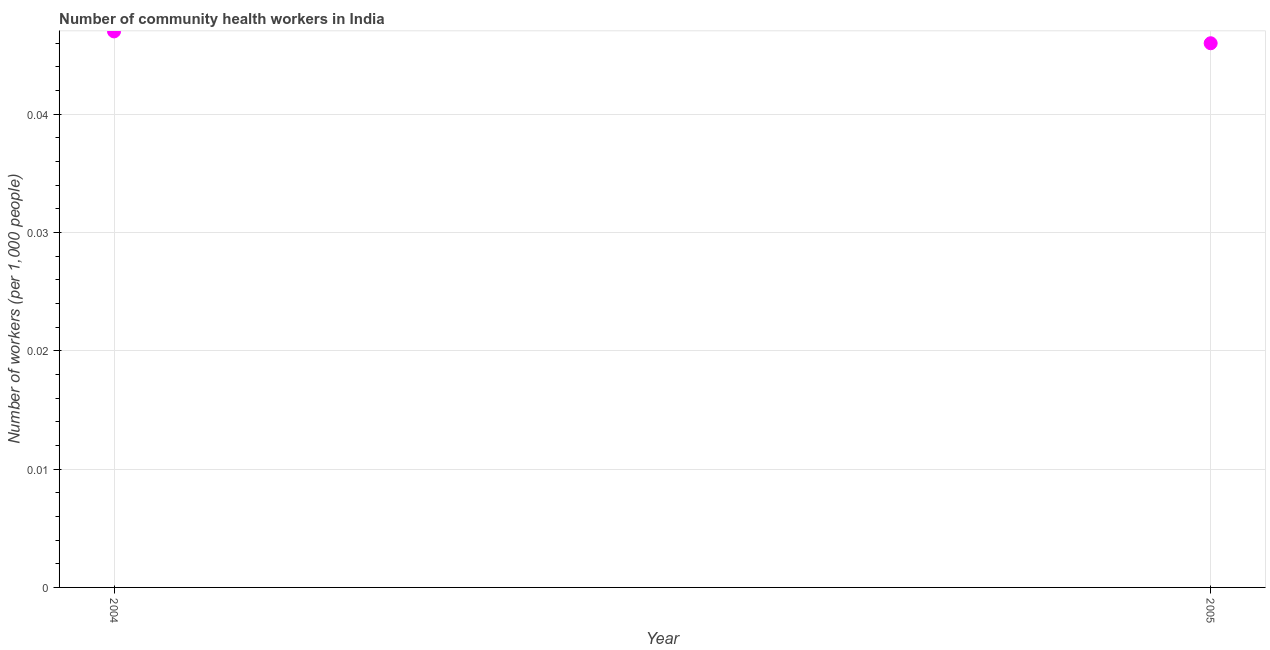What is the number of community health workers in 2005?
Keep it short and to the point. 0.05. Across all years, what is the maximum number of community health workers?
Provide a succinct answer. 0.05. Across all years, what is the minimum number of community health workers?
Your answer should be very brief. 0.05. What is the sum of the number of community health workers?
Your answer should be very brief. 0.09. What is the difference between the number of community health workers in 2004 and 2005?
Offer a very short reply. 0. What is the average number of community health workers per year?
Offer a terse response. 0.05. What is the median number of community health workers?
Your answer should be very brief. 0.05. In how many years, is the number of community health workers greater than 0.01 ?
Provide a succinct answer. 2. Do a majority of the years between 2005 and 2004 (inclusive) have number of community health workers greater than 0.032 ?
Your answer should be very brief. No. What is the ratio of the number of community health workers in 2004 to that in 2005?
Offer a terse response. 1.02. In how many years, is the number of community health workers greater than the average number of community health workers taken over all years?
Your answer should be compact. 1. How many dotlines are there?
Provide a succinct answer. 1. What is the difference between two consecutive major ticks on the Y-axis?
Give a very brief answer. 0.01. Are the values on the major ticks of Y-axis written in scientific E-notation?
Ensure brevity in your answer.  No. Does the graph contain grids?
Keep it short and to the point. Yes. What is the title of the graph?
Ensure brevity in your answer.  Number of community health workers in India. What is the label or title of the Y-axis?
Provide a short and direct response. Number of workers (per 1,0 people). What is the Number of workers (per 1,000 people) in 2004?
Give a very brief answer. 0.05. What is the Number of workers (per 1,000 people) in 2005?
Keep it short and to the point. 0.05. What is the difference between the Number of workers (per 1,000 people) in 2004 and 2005?
Give a very brief answer. 0. What is the ratio of the Number of workers (per 1,000 people) in 2004 to that in 2005?
Provide a succinct answer. 1.02. 